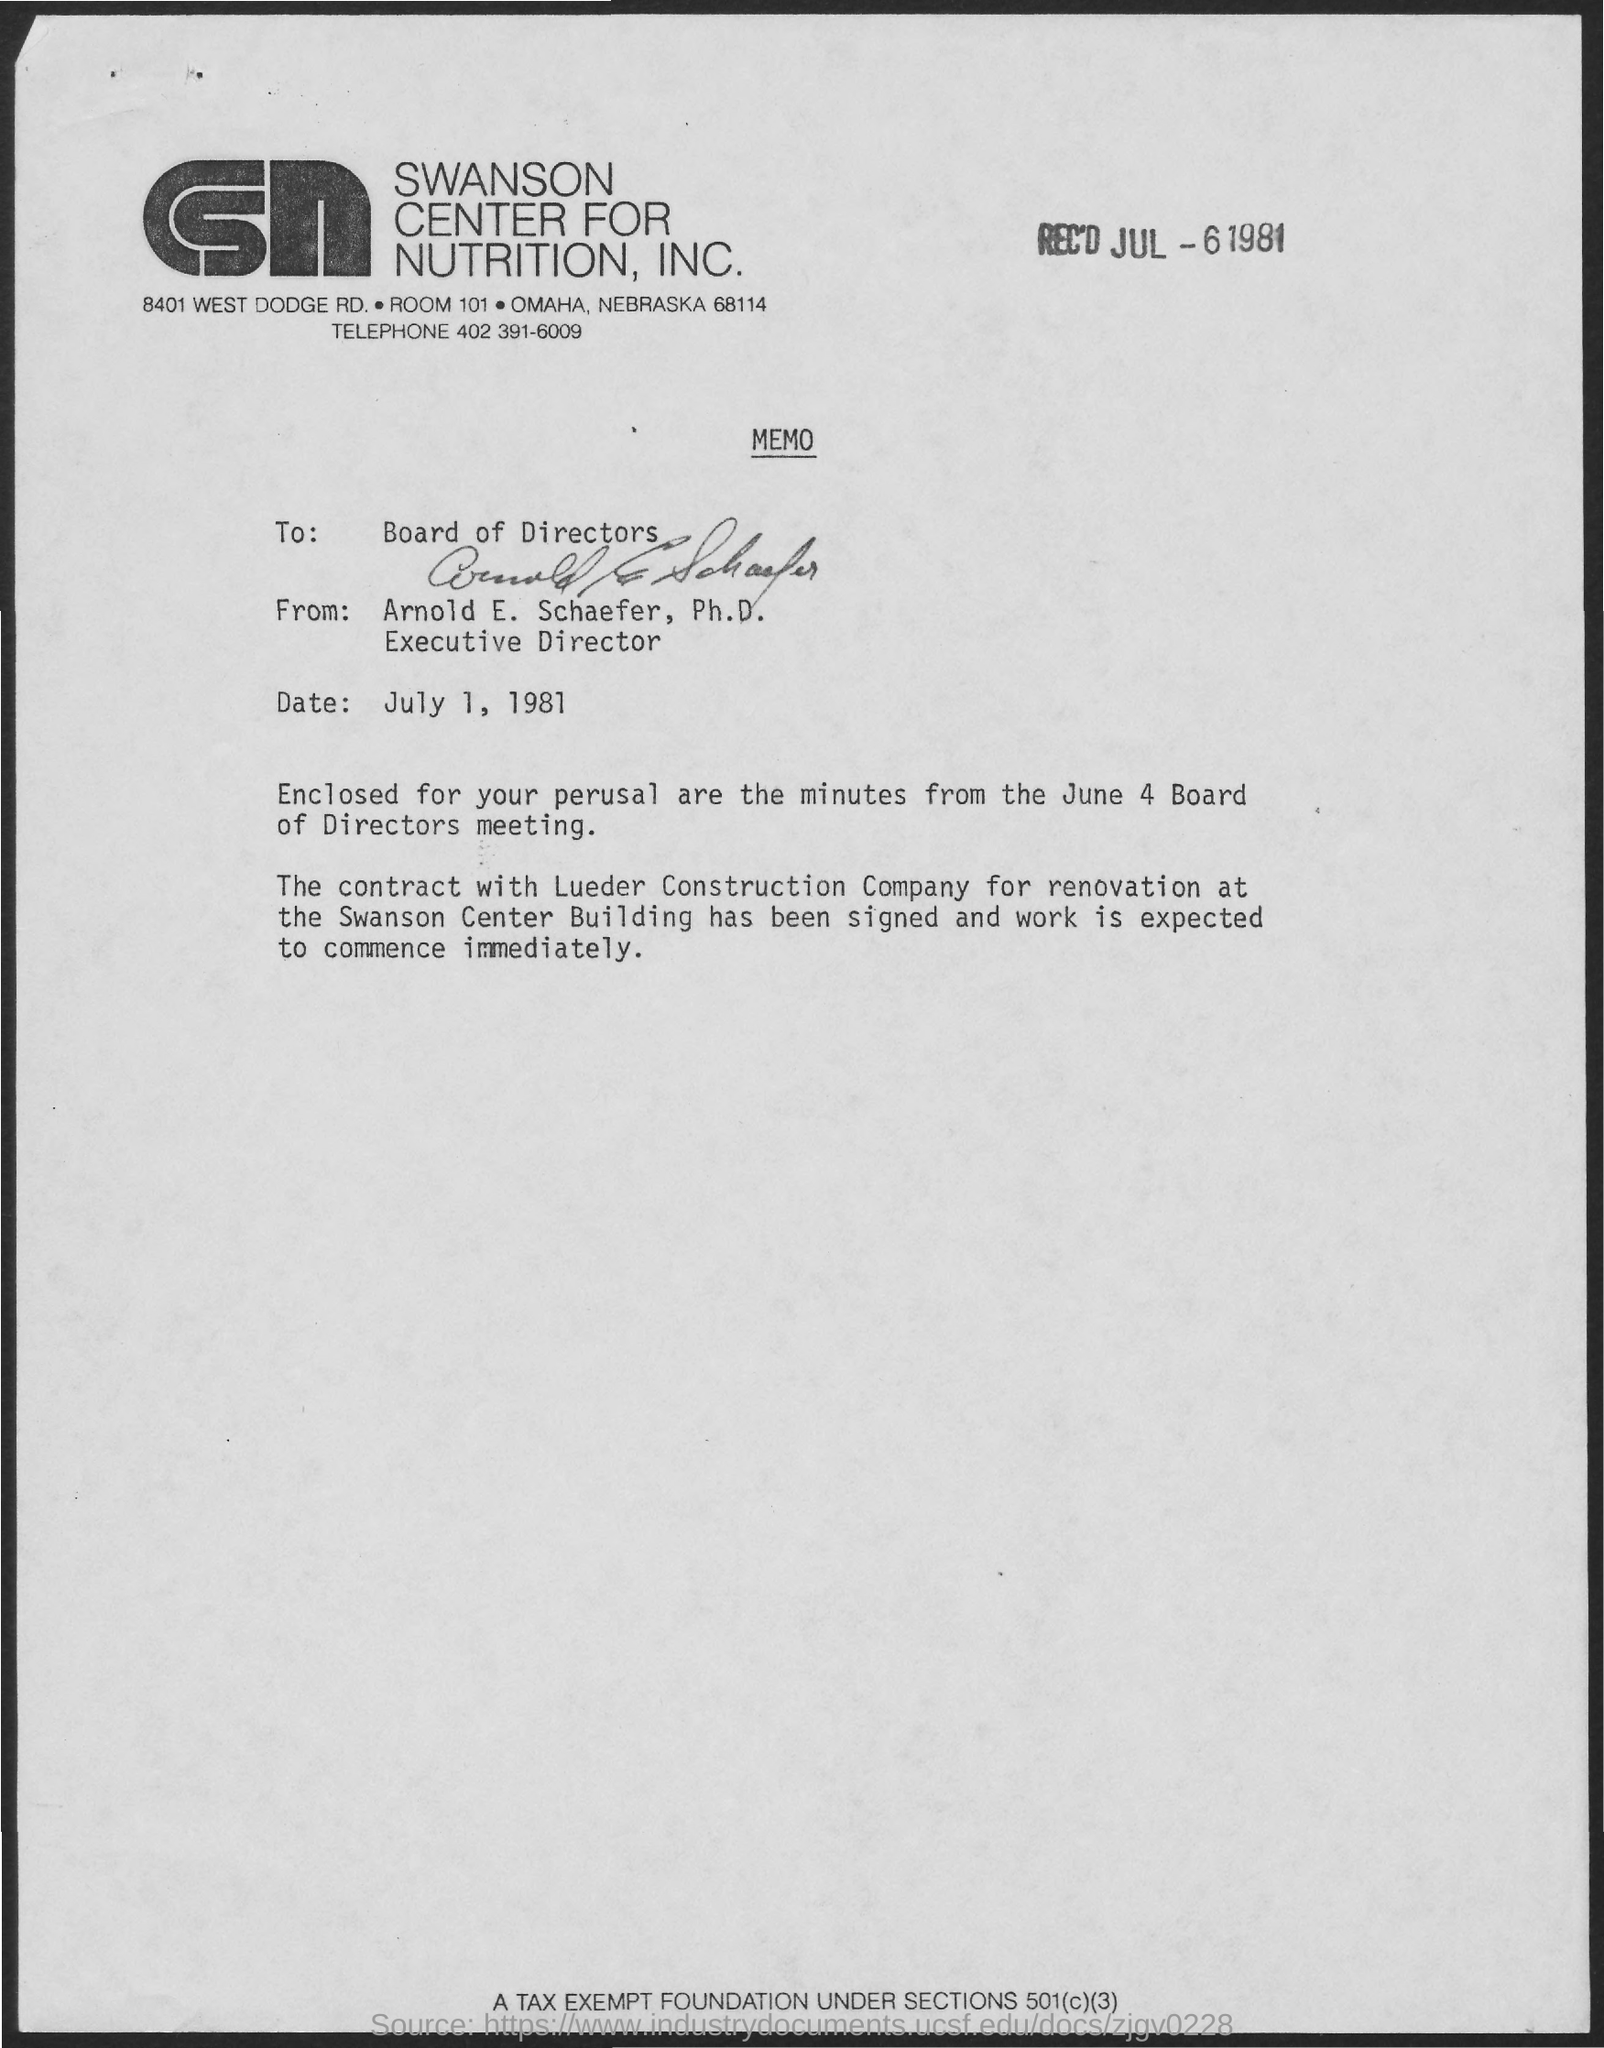Specify some key components in this picture. The issued date of this memo is July 1, 1981. This memo is addressed to the board of directors. The sender of this memo is Arnold E. Schaefer, Ph.D. Arnold E. Schaefer, Ph.D. holds the designation of Executive Director. The given memo belongs to the company known as Swanson Center for Nutrition, Inc. 